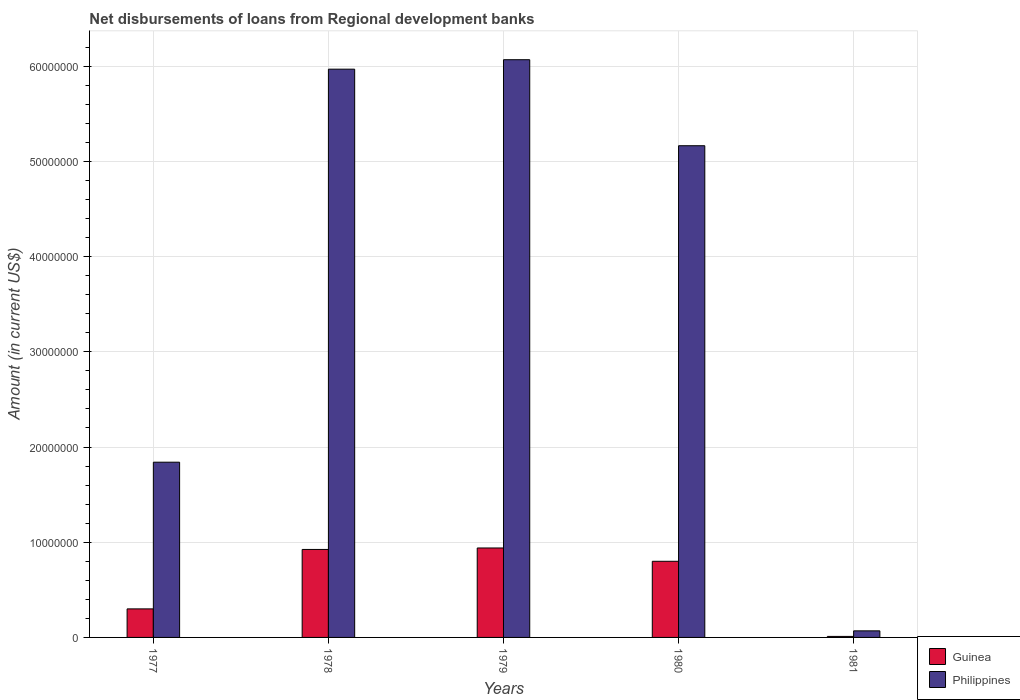How many different coloured bars are there?
Offer a very short reply. 2. How many bars are there on the 3rd tick from the right?
Ensure brevity in your answer.  2. What is the label of the 2nd group of bars from the left?
Your answer should be very brief. 1978. In how many cases, is the number of bars for a given year not equal to the number of legend labels?
Give a very brief answer. 0. What is the amount of disbursements of loans from regional development banks in Philippines in 1979?
Provide a succinct answer. 6.07e+07. Across all years, what is the maximum amount of disbursements of loans from regional development banks in Philippines?
Provide a succinct answer. 6.07e+07. Across all years, what is the minimum amount of disbursements of loans from regional development banks in Guinea?
Offer a terse response. 1.07e+05. In which year was the amount of disbursements of loans from regional development banks in Guinea maximum?
Give a very brief answer. 1979. What is the total amount of disbursements of loans from regional development banks in Guinea in the graph?
Give a very brief answer. 2.97e+07. What is the difference between the amount of disbursements of loans from regional development banks in Guinea in 1977 and that in 1978?
Keep it short and to the point. -6.24e+06. What is the difference between the amount of disbursements of loans from regional development banks in Philippines in 1981 and the amount of disbursements of loans from regional development banks in Guinea in 1977?
Provide a short and direct response. -2.31e+06. What is the average amount of disbursements of loans from regional development banks in Philippines per year?
Keep it short and to the point. 3.82e+07. In the year 1981, what is the difference between the amount of disbursements of loans from regional development banks in Philippines and amount of disbursements of loans from regional development banks in Guinea?
Your response must be concise. 5.83e+05. What is the ratio of the amount of disbursements of loans from regional development banks in Philippines in 1979 to that in 1980?
Your answer should be compact. 1.17. Is the amount of disbursements of loans from regional development banks in Guinea in 1980 less than that in 1981?
Ensure brevity in your answer.  No. Is the difference between the amount of disbursements of loans from regional development banks in Philippines in 1977 and 1981 greater than the difference between the amount of disbursements of loans from regional development banks in Guinea in 1977 and 1981?
Provide a short and direct response. Yes. What is the difference between the highest and the second highest amount of disbursements of loans from regional development banks in Philippines?
Your answer should be very brief. 9.93e+05. What is the difference between the highest and the lowest amount of disbursements of loans from regional development banks in Guinea?
Offer a terse response. 9.29e+06. In how many years, is the amount of disbursements of loans from regional development banks in Philippines greater than the average amount of disbursements of loans from regional development banks in Philippines taken over all years?
Provide a succinct answer. 3. Is the sum of the amount of disbursements of loans from regional development banks in Philippines in 1979 and 1981 greater than the maximum amount of disbursements of loans from regional development banks in Guinea across all years?
Ensure brevity in your answer.  Yes. What does the 2nd bar from the left in 1980 represents?
Provide a short and direct response. Philippines. What does the 2nd bar from the right in 1978 represents?
Give a very brief answer. Guinea. Are all the bars in the graph horizontal?
Your response must be concise. No. How many years are there in the graph?
Give a very brief answer. 5. Are the values on the major ticks of Y-axis written in scientific E-notation?
Make the answer very short. No. Does the graph contain any zero values?
Your answer should be very brief. No. Does the graph contain grids?
Provide a succinct answer. Yes. How are the legend labels stacked?
Your answer should be very brief. Vertical. What is the title of the graph?
Offer a very short reply. Net disbursements of loans from Regional development banks. Does "Ethiopia" appear as one of the legend labels in the graph?
Offer a terse response. No. What is the Amount (in current US$) in Guinea in 1977?
Provide a short and direct response. 3.00e+06. What is the Amount (in current US$) in Philippines in 1977?
Keep it short and to the point. 1.84e+07. What is the Amount (in current US$) in Guinea in 1978?
Ensure brevity in your answer.  9.24e+06. What is the Amount (in current US$) of Philippines in 1978?
Make the answer very short. 5.97e+07. What is the Amount (in current US$) of Guinea in 1979?
Your answer should be very brief. 9.40e+06. What is the Amount (in current US$) of Philippines in 1979?
Keep it short and to the point. 6.07e+07. What is the Amount (in current US$) in Guinea in 1980?
Ensure brevity in your answer.  8.00e+06. What is the Amount (in current US$) in Philippines in 1980?
Your answer should be very brief. 5.16e+07. What is the Amount (in current US$) of Guinea in 1981?
Ensure brevity in your answer.  1.07e+05. What is the Amount (in current US$) of Philippines in 1981?
Offer a terse response. 6.90e+05. Across all years, what is the maximum Amount (in current US$) of Guinea?
Provide a succinct answer. 9.40e+06. Across all years, what is the maximum Amount (in current US$) in Philippines?
Keep it short and to the point. 6.07e+07. Across all years, what is the minimum Amount (in current US$) of Guinea?
Your answer should be very brief. 1.07e+05. Across all years, what is the minimum Amount (in current US$) in Philippines?
Your response must be concise. 6.90e+05. What is the total Amount (in current US$) in Guinea in the graph?
Give a very brief answer. 2.97e+07. What is the total Amount (in current US$) in Philippines in the graph?
Provide a short and direct response. 1.91e+08. What is the difference between the Amount (in current US$) of Guinea in 1977 and that in 1978?
Give a very brief answer. -6.24e+06. What is the difference between the Amount (in current US$) of Philippines in 1977 and that in 1978?
Offer a very short reply. -4.13e+07. What is the difference between the Amount (in current US$) in Guinea in 1977 and that in 1979?
Offer a terse response. -6.40e+06. What is the difference between the Amount (in current US$) in Philippines in 1977 and that in 1979?
Provide a short and direct response. -4.23e+07. What is the difference between the Amount (in current US$) of Guinea in 1977 and that in 1980?
Offer a very short reply. -5.00e+06. What is the difference between the Amount (in current US$) in Philippines in 1977 and that in 1980?
Provide a short and direct response. -3.32e+07. What is the difference between the Amount (in current US$) of Guinea in 1977 and that in 1981?
Make the answer very short. 2.89e+06. What is the difference between the Amount (in current US$) in Philippines in 1977 and that in 1981?
Provide a short and direct response. 1.77e+07. What is the difference between the Amount (in current US$) in Guinea in 1978 and that in 1979?
Your answer should be compact. -1.55e+05. What is the difference between the Amount (in current US$) in Philippines in 1978 and that in 1979?
Provide a succinct answer. -9.93e+05. What is the difference between the Amount (in current US$) of Guinea in 1978 and that in 1980?
Your response must be concise. 1.24e+06. What is the difference between the Amount (in current US$) of Philippines in 1978 and that in 1980?
Your answer should be very brief. 8.04e+06. What is the difference between the Amount (in current US$) in Guinea in 1978 and that in 1981?
Offer a very short reply. 9.13e+06. What is the difference between the Amount (in current US$) of Philippines in 1978 and that in 1981?
Provide a short and direct response. 5.90e+07. What is the difference between the Amount (in current US$) of Guinea in 1979 and that in 1980?
Offer a terse response. 1.40e+06. What is the difference between the Amount (in current US$) of Philippines in 1979 and that in 1980?
Give a very brief answer. 9.03e+06. What is the difference between the Amount (in current US$) of Guinea in 1979 and that in 1981?
Your response must be concise. 9.29e+06. What is the difference between the Amount (in current US$) of Philippines in 1979 and that in 1981?
Give a very brief answer. 6.00e+07. What is the difference between the Amount (in current US$) in Guinea in 1980 and that in 1981?
Provide a short and direct response. 7.89e+06. What is the difference between the Amount (in current US$) in Philippines in 1980 and that in 1981?
Your answer should be compact. 5.10e+07. What is the difference between the Amount (in current US$) in Guinea in 1977 and the Amount (in current US$) in Philippines in 1978?
Your answer should be very brief. -5.67e+07. What is the difference between the Amount (in current US$) of Guinea in 1977 and the Amount (in current US$) of Philippines in 1979?
Provide a succinct answer. -5.77e+07. What is the difference between the Amount (in current US$) in Guinea in 1977 and the Amount (in current US$) in Philippines in 1980?
Provide a succinct answer. -4.86e+07. What is the difference between the Amount (in current US$) in Guinea in 1977 and the Amount (in current US$) in Philippines in 1981?
Offer a terse response. 2.31e+06. What is the difference between the Amount (in current US$) in Guinea in 1978 and the Amount (in current US$) in Philippines in 1979?
Provide a succinct answer. -5.14e+07. What is the difference between the Amount (in current US$) in Guinea in 1978 and the Amount (in current US$) in Philippines in 1980?
Ensure brevity in your answer.  -4.24e+07. What is the difference between the Amount (in current US$) in Guinea in 1978 and the Amount (in current US$) in Philippines in 1981?
Provide a succinct answer. 8.55e+06. What is the difference between the Amount (in current US$) of Guinea in 1979 and the Amount (in current US$) of Philippines in 1980?
Make the answer very short. -4.23e+07. What is the difference between the Amount (in current US$) of Guinea in 1979 and the Amount (in current US$) of Philippines in 1981?
Your answer should be very brief. 8.71e+06. What is the difference between the Amount (in current US$) of Guinea in 1980 and the Amount (in current US$) of Philippines in 1981?
Your response must be concise. 7.31e+06. What is the average Amount (in current US$) of Guinea per year?
Make the answer very short. 5.95e+06. What is the average Amount (in current US$) in Philippines per year?
Provide a short and direct response. 3.82e+07. In the year 1977, what is the difference between the Amount (in current US$) in Guinea and Amount (in current US$) in Philippines?
Provide a succinct answer. -1.54e+07. In the year 1978, what is the difference between the Amount (in current US$) in Guinea and Amount (in current US$) in Philippines?
Provide a succinct answer. -5.04e+07. In the year 1979, what is the difference between the Amount (in current US$) in Guinea and Amount (in current US$) in Philippines?
Offer a very short reply. -5.13e+07. In the year 1980, what is the difference between the Amount (in current US$) of Guinea and Amount (in current US$) of Philippines?
Give a very brief answer. -4.36e+07. In the year 1981, what is the difference between the Amount (in current US$) in Guinea and Amount (in current US$) in Philippines?
Offer a terse response. -5.83e+05. What is the ratio of the Amount (in current US$) of Guinea in 1977 to that in 1978?
Offer a very short reply. 0.32. What is the ratio of the Amount (in current US$) in Philippines in 1977 to that in 1978?
Your answer should be very brief. 0.31. What is the ratio of the Amount (in current US$) in Guinea in 1977 to that in 1979?
Provide a succinct answer. 0.32. What is the ratio of the Amount (in current US$) in Philippines in 1977 to that in 1979?
Your answer should be compact. 0.3. What is the ratio of the Amount (in current US$) in Guinea in 1977 to that in 1980?
Provide a succinct answer. 0.37. What is the ratio of the Amount (in current US$) of Philippines in 1977 to that in 1980?
Keep it short and to the point. 0.36. What is the ratio of the Amount (in current US$) of Guinea in 1977 to that in 1981?
Provide a short and direct response. 28.02. What is the ratio of the Amount (in current US$) in Philippines in 1977 to that in 1981?
Your answer should be compact. 26.68. What is the ratio of the Amount (in current US$) in Guinea in 1978 to that in 1979?
Make the answer very short. 0.98. What is the ratio of the Amount (in current US$) in Philippines in 1978 to that in 1979?
Make the answer very short. 0.98. What is the ratio of the Amount (in current US$) in Guinea in 1978 to that in 1980?
Offer a terse response. 1.16. What is the ratio of the Amount (in current US$) of Philippines in 1978 to that in 1980?
Offer a very short reply. 1.16. What is the ratio of the Amount (in current US$) in Guinea in 1978 to that in 1981?
Your response must be concise. 86.36. What is the ratio of the Amount (in current US$) of Philippines in 1978 to that in 1981?
Make the answer very short. 86.5. What is the ratio of the Amount (in current US$) of Guinea in 1979 to that in 1980?
Offer a terse response. 1.17. What is the ratio of the Amount (in current US$) in Philippines in 1979 to that in 1980?
Give a very brief answer. 1.17. What is the ratio of the Amount (in current US$) of Guinea in 1979 to that in 1981?
Your answer should be compact. 87.81. What is the ratio of the Amount (in current US$) of Philippines in 1979 to that in 1981?
Offer a terse response. 87.94. What is the ratio of the Amount (in current US$) in Guinea in 1980 to that in 1981?
Provide a succinct answer. 74.74. What is the ratio of the Amount (in current US$) in Philippines in 1980 to that in 1981?
Offer a very short reply. 74.85. What is the difference between the highest and the second highest Amount (in current US$) of Guinea?
Make the answer very short. 1.55e+05. What is the difference between the highest and the second highest Amount (in current US$) of Philippines?
Your response must be concise. 9.93e+05. What is the difference between the highest and the lowest Amount (in current US$) of Guinea?
Offer a terse response. 9.29e+06. What is the difference between the highest and the lowest Amount (in current US$) of Philippines?
Keep it short and to the point. 6.00e+07. 